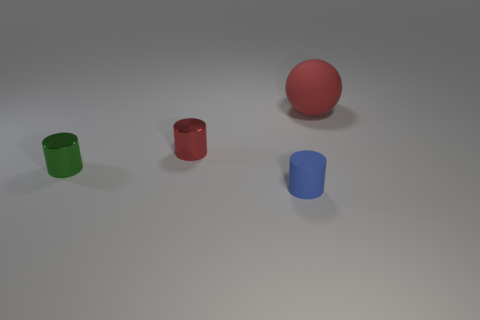What number of matte cylinders have the same color as the matte sphere?
Ensure brevity in your answer.  0. There is a large ball; is it the same color as the small metal cylinder that is behind the tiny green cylinder?
Provide a short and direct response. Yes. How many objects are small rubber cylinders or small cylinders that are behind the tiny rubber cylinder?
Offer a terse response. 3. There is a object to the right of the tiny cylinder in front of the small green shiny cylinder; how big is it?
Ensure brevity in your answer.  Large. Are there the same number of tiny cylinders that are on the right side of the red cylinder and green cylinders that are left of the small blue matte cylinder?
Make the answer very short. Yes. Are there any small metallic objects that are to the left of the metallic object behind the green thing?
Your answer should be compact. Yes. There is a thing that is the same material as the big sphere; what is its shape?
Provide a short and direct response. Cylinder. Are there any other things that are the same color as the tiny rubber thing?
Offer a terse response. No. The red thing that is in front of the thing that is behind the small red shiny thing is made of what material?
Provide a succinct answer. Metal. Is there a tiny red metal object that has the same shape as the red matte object?
Provide a short and direct response. No. 